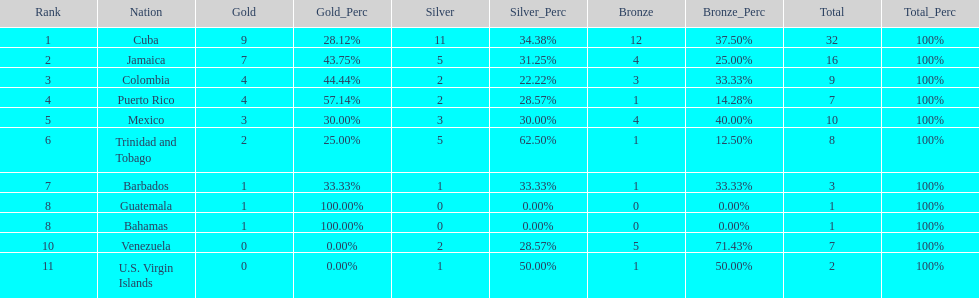Number of teams above 9 medals 3. 